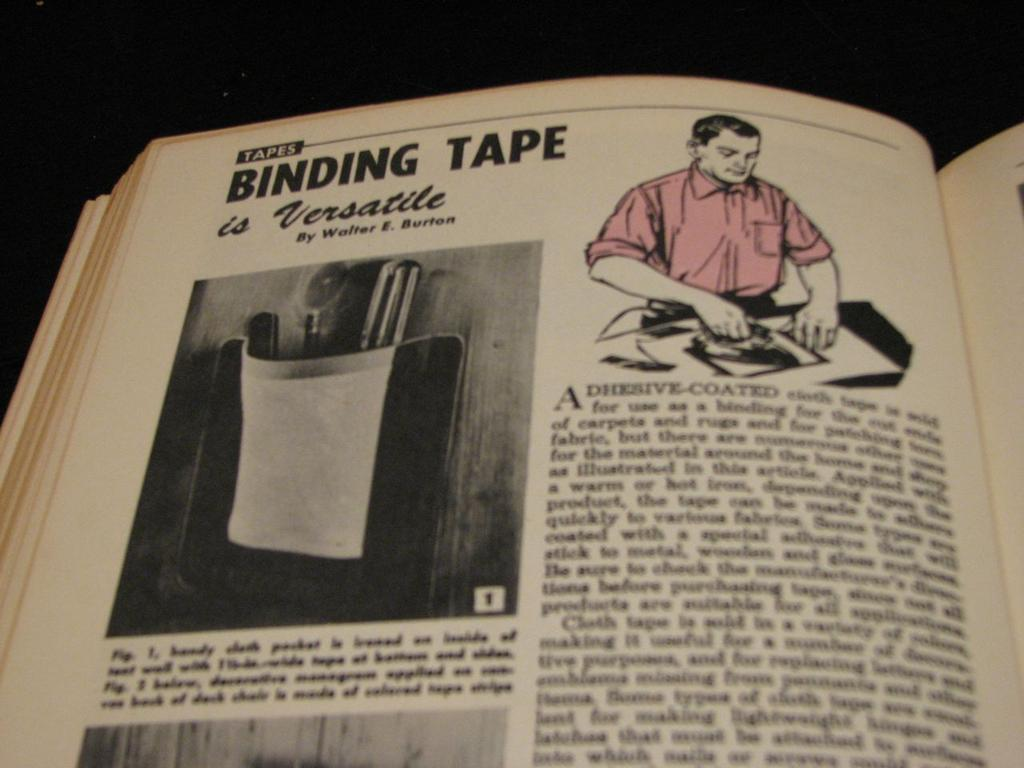<image>
Give a short and clear explanation of the subsequent image. A book chapter discusses the subject of Binding Tape and its versatility. 